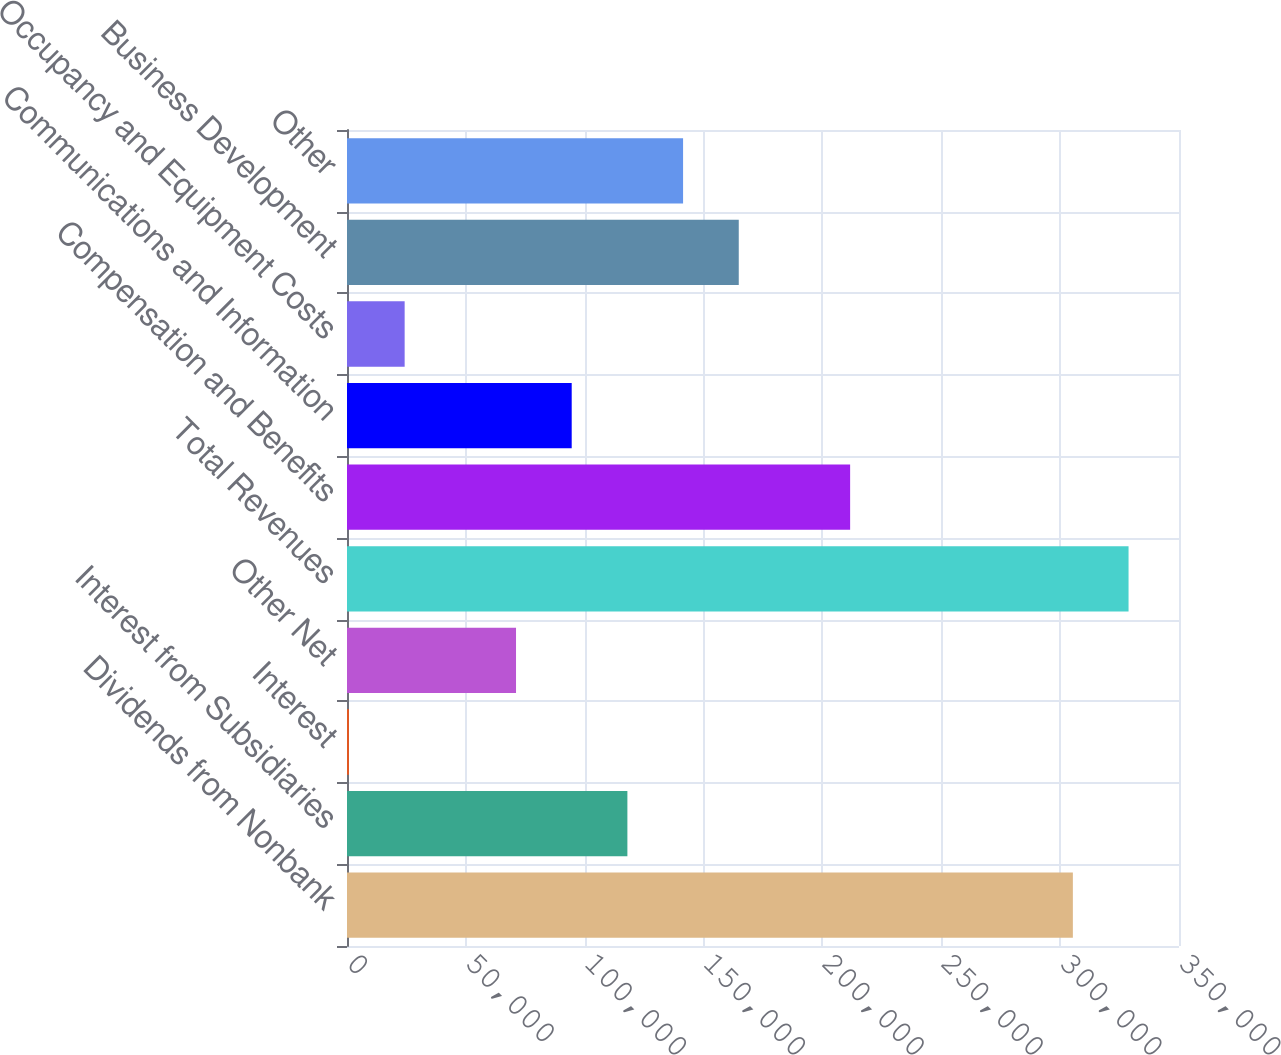Convert chart. <chart><loc_0><loc_0><loc_500><loc_500><bar_chart><fcel>Dividends from Nonbank<fcel>Interest from Subsidiaries<fcel>Interest<fcel>Other Net<fcel>Total Revenues<fcel>Compensation and Benefits<fcel>Communications and Information<fcel>Occupancy and Equipment Costs<fcel>Business Development<fcel>Other<nl><fcel>305353<fcel>117952<fcel>827<fcel>71102.3<fcel>328778<fcel>211653<fcel>94527.4<fcel>24252.1<fcel>164803<fcel>141378<nl></chart> 